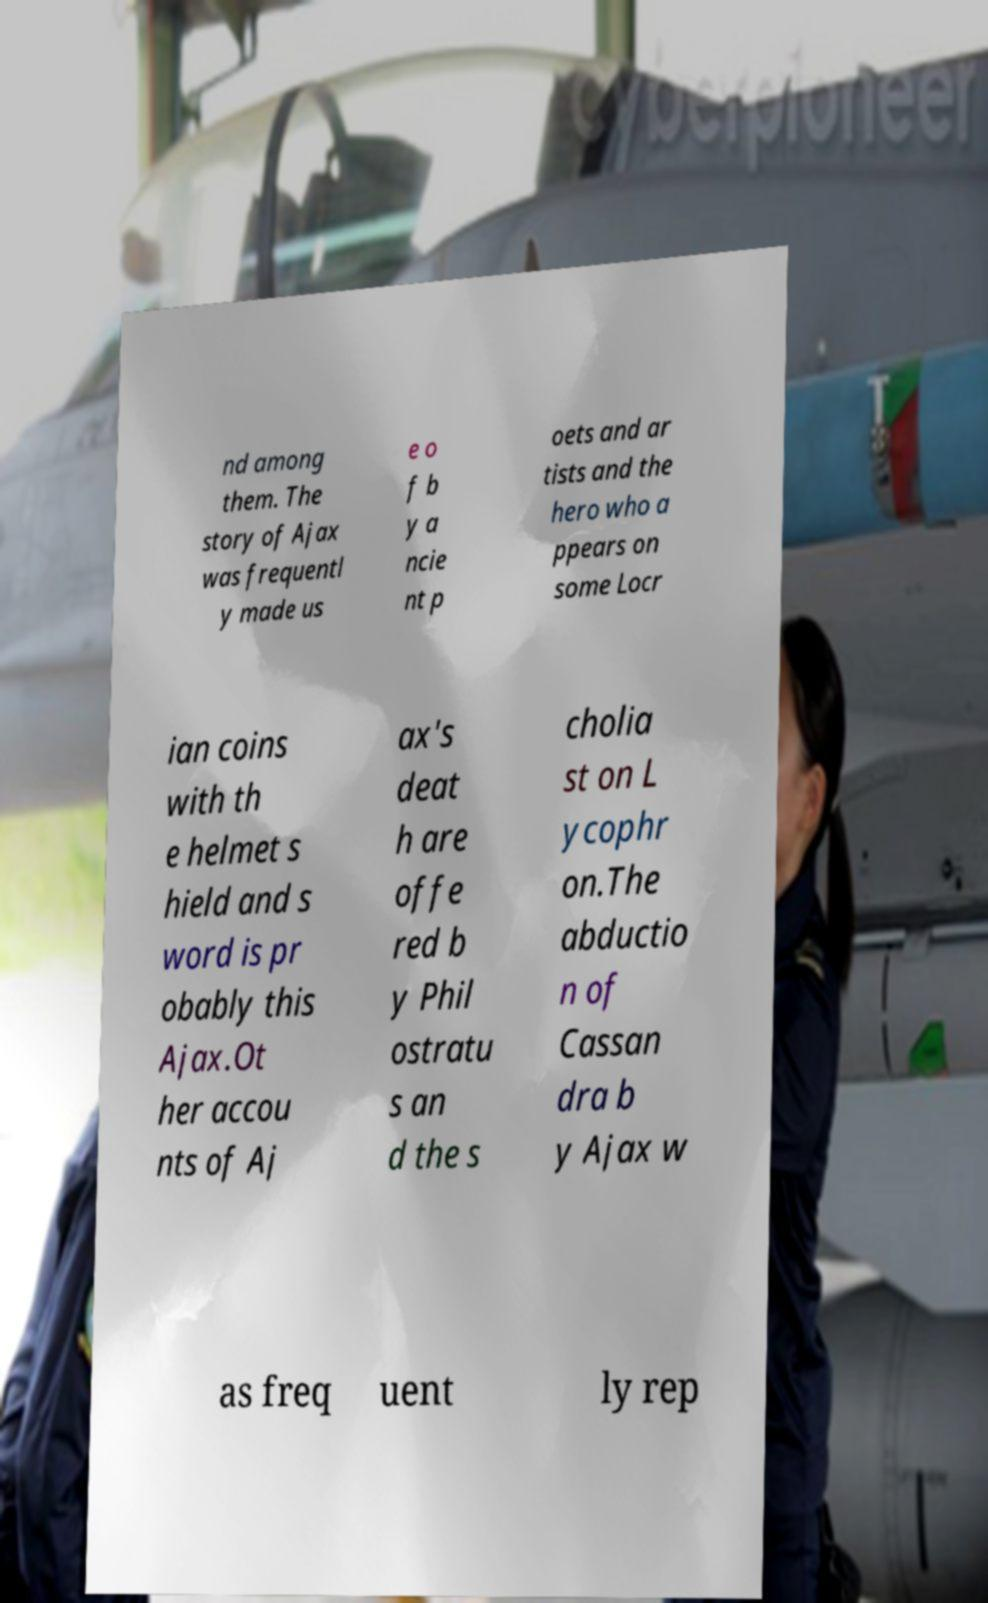I need the written content from this picture converted into text. Can you do that? nd among them. The story of Ajax was frequentl y made us e o f b y a ncie nt p oets and ar tists and the hero who a ppears on some Locr ian coins with th e helmet s hield and s word is pr obably this Ajax.Ot her accou nts of Aj ax's deat h are offe red b y Phil ostratu s an d the s cholia st on L ycophr on.The abductio n of Cassan dra b y Ajax w as freq uent ly rep 